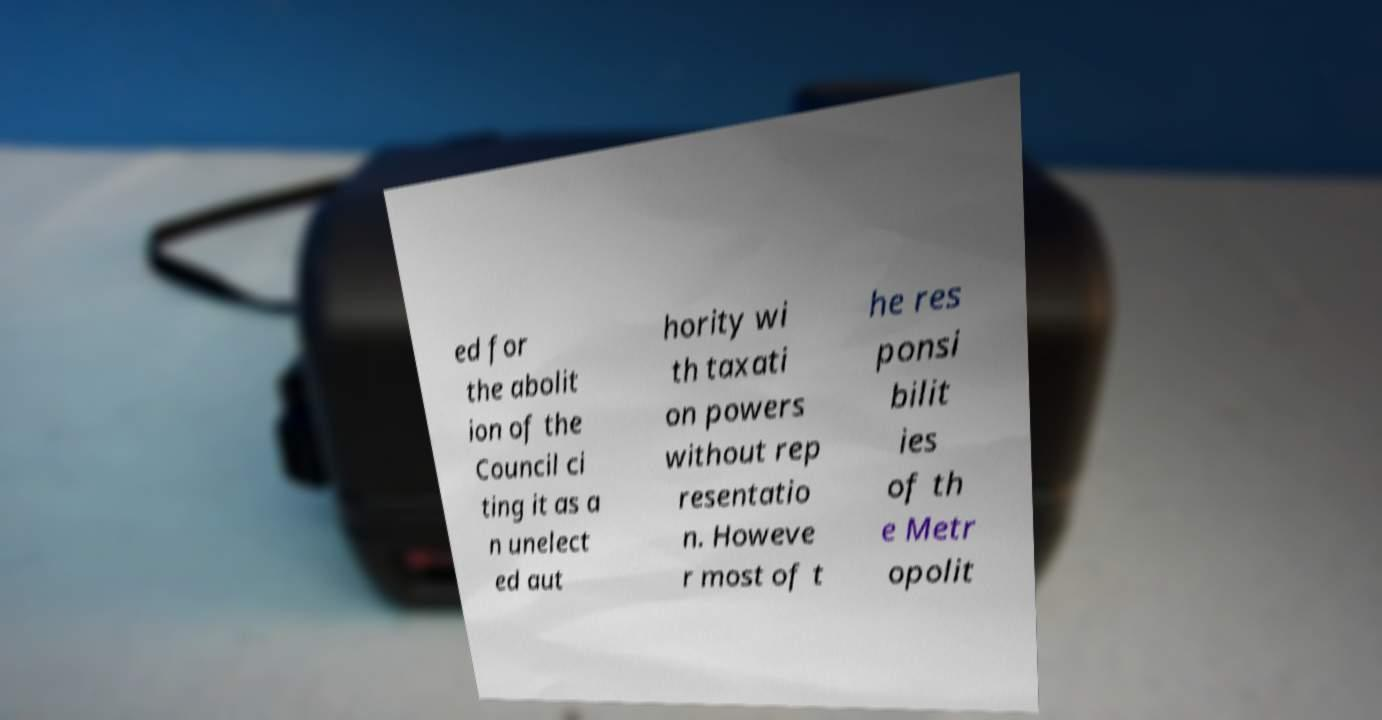I need the written content from this picture converted into text. Can you do that? ed for the abolit ion of the Council ci ting it as a n unelect ed aut hority wi th taxati on powers without rep resentatio n. Howeve r most of t he res ponsi bilit ies of th e Metr opolit 